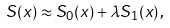Convert formula to latex. <formula><loc_0><loc_0><loc_500><loc_500>S ( x ) \approx S _ { 0 } ( x ) + \lambda S _ { 1 } ( x ) \, ,</formula> 